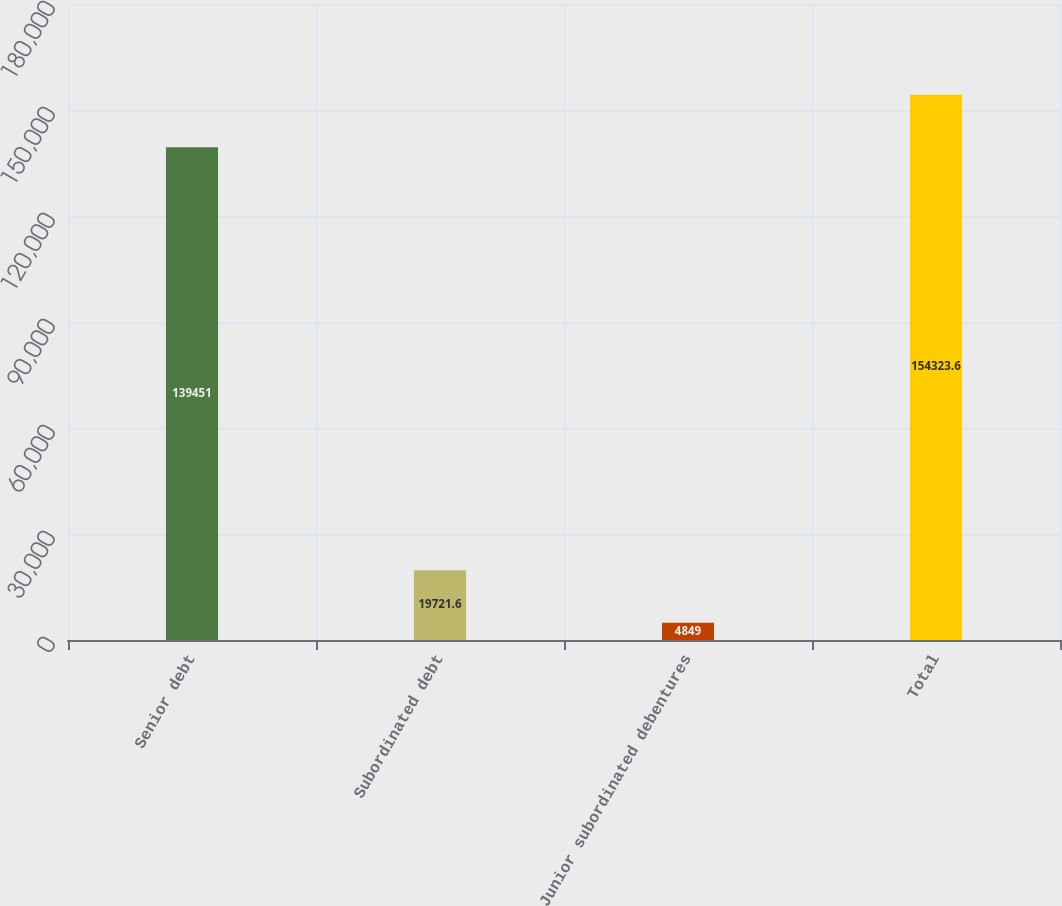Convert chart to OTSL. <chart><loc_0><loc_0><loc_500><loc_500><bar_chart><fcel>Senior debt<fcel>Subordinated debt<fcel>Junior subordinated debentures<fcel>Total<nl><fcel>139451<fcel>19721.6<fcel>4849<fcel>154324<nl></chart> 